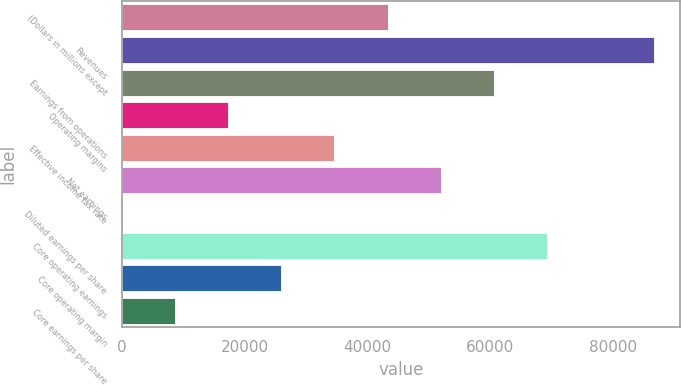Convert chart to OTSL. <chart><loc_0><loc_0><loc_500><loc_500><bar_chart><fcel>(Dollars in millions except<fcel>Revenues<fcel>Earnings from operations<fcel>Operating margins<fcel>Effective income tax rate<fcel>Net earnings<fcel>Diluted earnings per share<fcel>Core operating earnings<fcel>Core operating margin<fcel>Core earnings per share<nl><fcel>43314.5<fcel>86623<fcel>60637.9<fcel>17329.4<fcel>34652.8<fcel>51976.2<fcel>5.96<fcel>69299.6<fcel>25991.1<fcel>8667.66<nl></chart> 